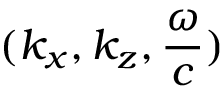<formula> <loc_0><loc_0><loc_500><loc_500>( k _ { x } , k _ { z } , \frac { \omega } { c } )</formula> 